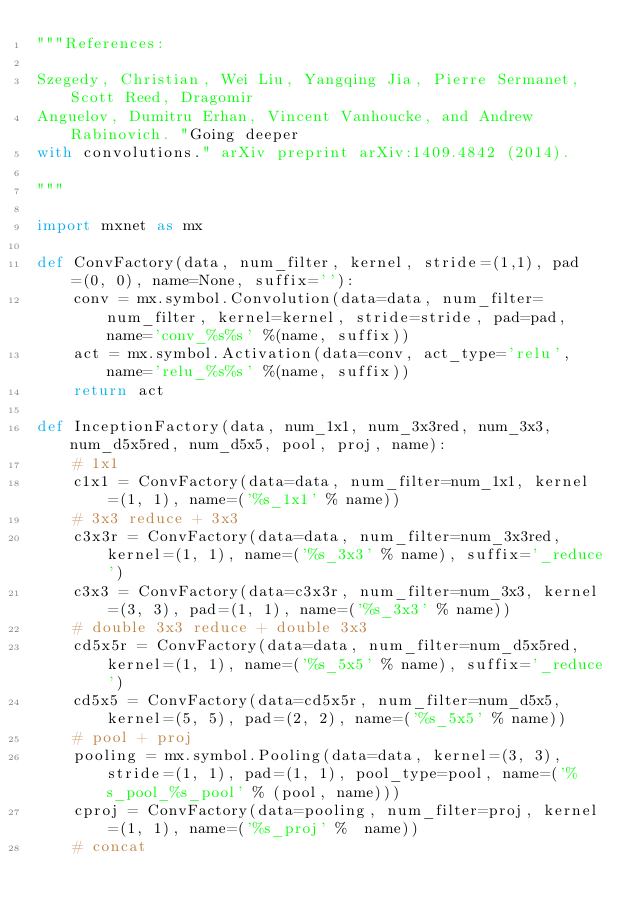<code> <loc_0><loc_0><loc_500><loc_500><_Python_>"""References:

Szegedy, Christian, Wei Liu, Yangqing Jia, Pierre Sermanet, Scott Reed, Dragomir
Anguelov, Dumitru Erhan, Vincent Vanhoucke, and Andrew Rabinovich. "Going deeper
with convolutions." arXiv preprint arXiv:1409.4842 (2014).

"""

import mxnet as mx

def ConvFactory(data, num_filter, kernel, stride=(1,1), pad=(0, 0), name=None, suffix=''):
    conv = mx.symbol.Convolution(data=data, num_filter=num_filter, kernel=kernel, stride=stride, pad=pad, name='conv_%s%s' %(name, suffix))
    act = mx.symbol.Activation(data=conv, act_type='relu', name='relu_%s%s' %(name, suffix))
    return act

def InceptionFactory(data, num_1x1, num_3x3red, num_3x3, num_d5x5red, num_d5x5, pool, proj, name):
    # 1x1
    c1x1 = ConvFactory(data=data, num_filter=num_1x1, kernel=(1, 1), name=('%s_1x1' % name))
    # 3x3 reduce + 3x3
    c3x3r = ConvFactory(data=data, num_filter=num_3x3red, kernel=(1, 1), name=('%s_3x3' % name), suffix='_reduce')
    c3x3 = ConvFactory(data=c3x3r, num_filter=num_3x3, kernel=(3, 3), pad=(1, 1), name=('%s_3x3' % name))
    # double 3x3 reduce + double 3x3
    cd5x5r = ConvFactory(data=data, num_filter=num_d5x5red, kernel=(1, 1), name=('%s_5x5' % name), suffix='_reduce')
    cd5x5 = ConvFactory(data=cd5x5r, num_filter=num_d5x5, kernel=(5, 5), pad=(2, 2), name=('%s_5x5' % name))
    # pool + proj
    pooling = mx.symbol.Pooling(data=data, kernel=(3, 3), stride=(1, 1), pad=(1, 1), pool_type=pool, name=('%s_pool_%s_pool' % (pool, name)))
    cproj = ConvFactory(data=pooling, num_filter=proj, kernel=(1, 1), name=('%s_proj' %  name))
    # concat</code> 